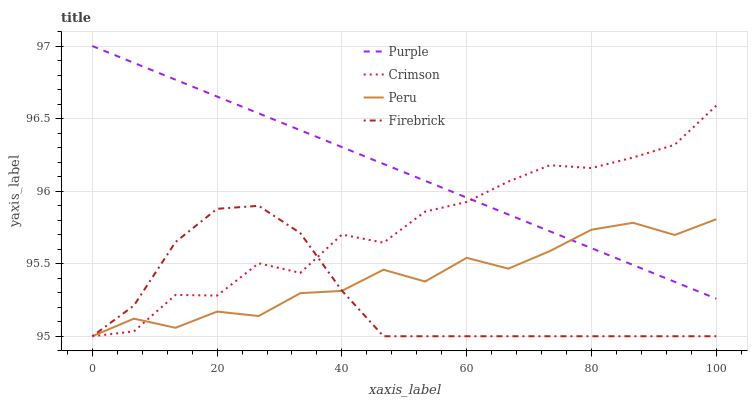Does Firebrick have the minimum area under the curve?
Answer yes or no. Yes. Does Purple have the maximum area under the curve?
Answer yes or no. Yes. Does Crimson have the minimum area under the curve?
Answer yes or no. No. Does Crimson have the maximum area under the curve?
Answer yes or no. No. Is Purple the smoothest?
Answer yes or no. Yes. Is Crimson the roughest?
Answer yes or no. Yes. Is Firebrick the smoothest?
Answer yes or no. No. Is Firebrick the roughest?
Answer yes or no. No. Does Crimson have the lowest value?
Answer yes or no. Yes. Does Purple have the highest value?
Answer yes or no. Yes. Does Crimson have the highest value?
Answer yes or no. No. Is Firebrick less than Purple?
Answer yes or no. Yes. Is Purple greater than Firebrick?
Answer yes or no. Yes. Does Firebrick intersect Peru?
Answer yes or no. Yes. Is Firebrick less than Peru?
Answer yes or no. No. Is Firebrick greater than Peru?
Answer yes or no. No. Does Firebrick intersect Purple?
Answer yes or no. No. 